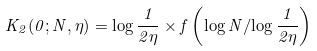<formula> <loc_0><loc_0><loc_500><loc_500>K _ { 2 } ( 0 ; N , \eta ) = \log \frac { 1 } { 2 \eta } \times f \left ( { \log N } / { \log \frac { 1 } { 2 \eta } } \right )</formula> 